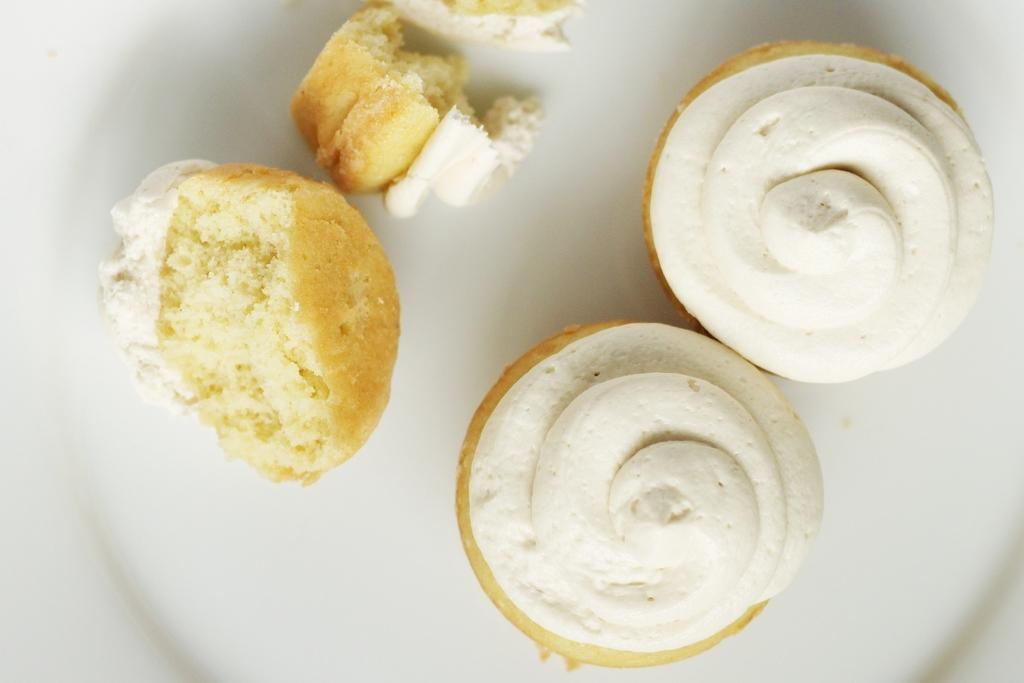What type of food is visible in the image? There are cupcakes in the image. Where are the cupcakes located? The cupcakes are on a plate. What is the value of the prison in the image? There is no prison present in the image, so it is not possible to determine its value. 